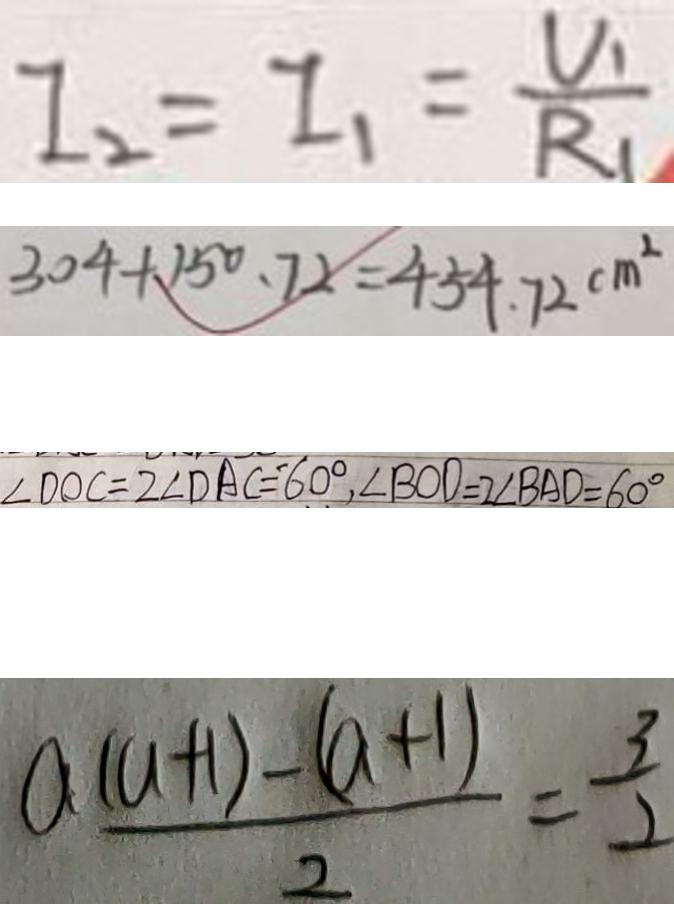Convert formula to latex. <formula><loc_0><loc_0><loc_500><loc_500>I _ { 2 } = I _ { 1 } = \frac { U _ { 1 } } { R _ { 1 } } 
 3 0 4 + 1 5 0 . 7 2 = 4 5 4 . 7 2 c m ^ { 2 } 
 \angle D O C = 2 \angle D A C = ^ { \prime } 6 0 ^ { \circ } , \angle B O D = 2 \angle B A D = 6 0 ^ { \circ } 
 \frac { a ( a + 1 ) - ( a + 1 ) } { 2 } = \frac { 3 } { 2 }</formula> 